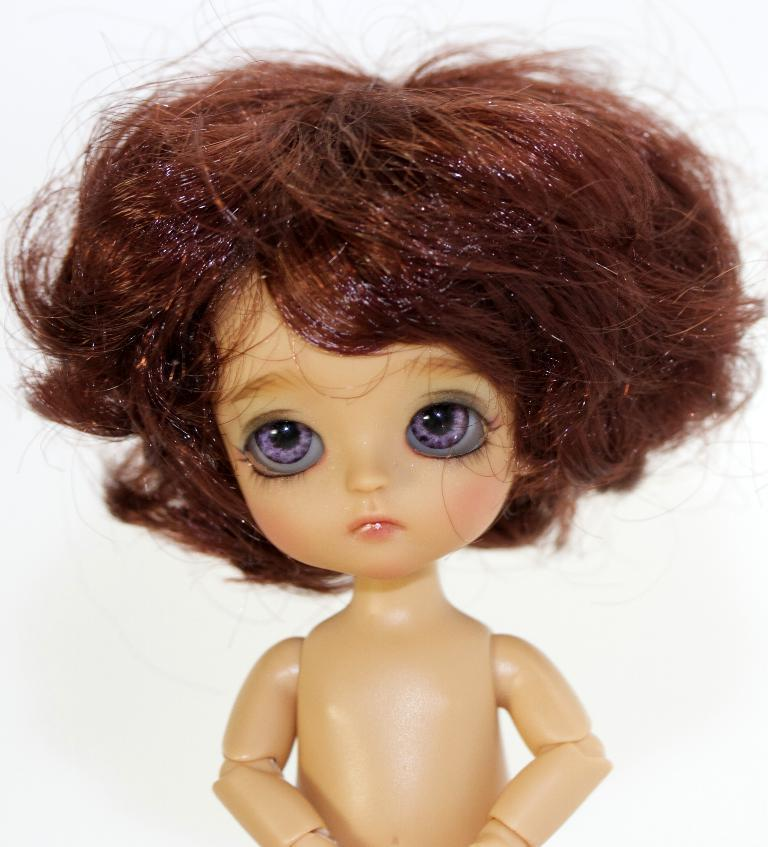What is the main subject of the image? There is a doll in the image. What color is the background of the image? The background of the image is white. Where is the key located in the image? There is no key present in the image. What type of hill can be seen in the background of the image? There is no hill visible in the image, as the background is white. 